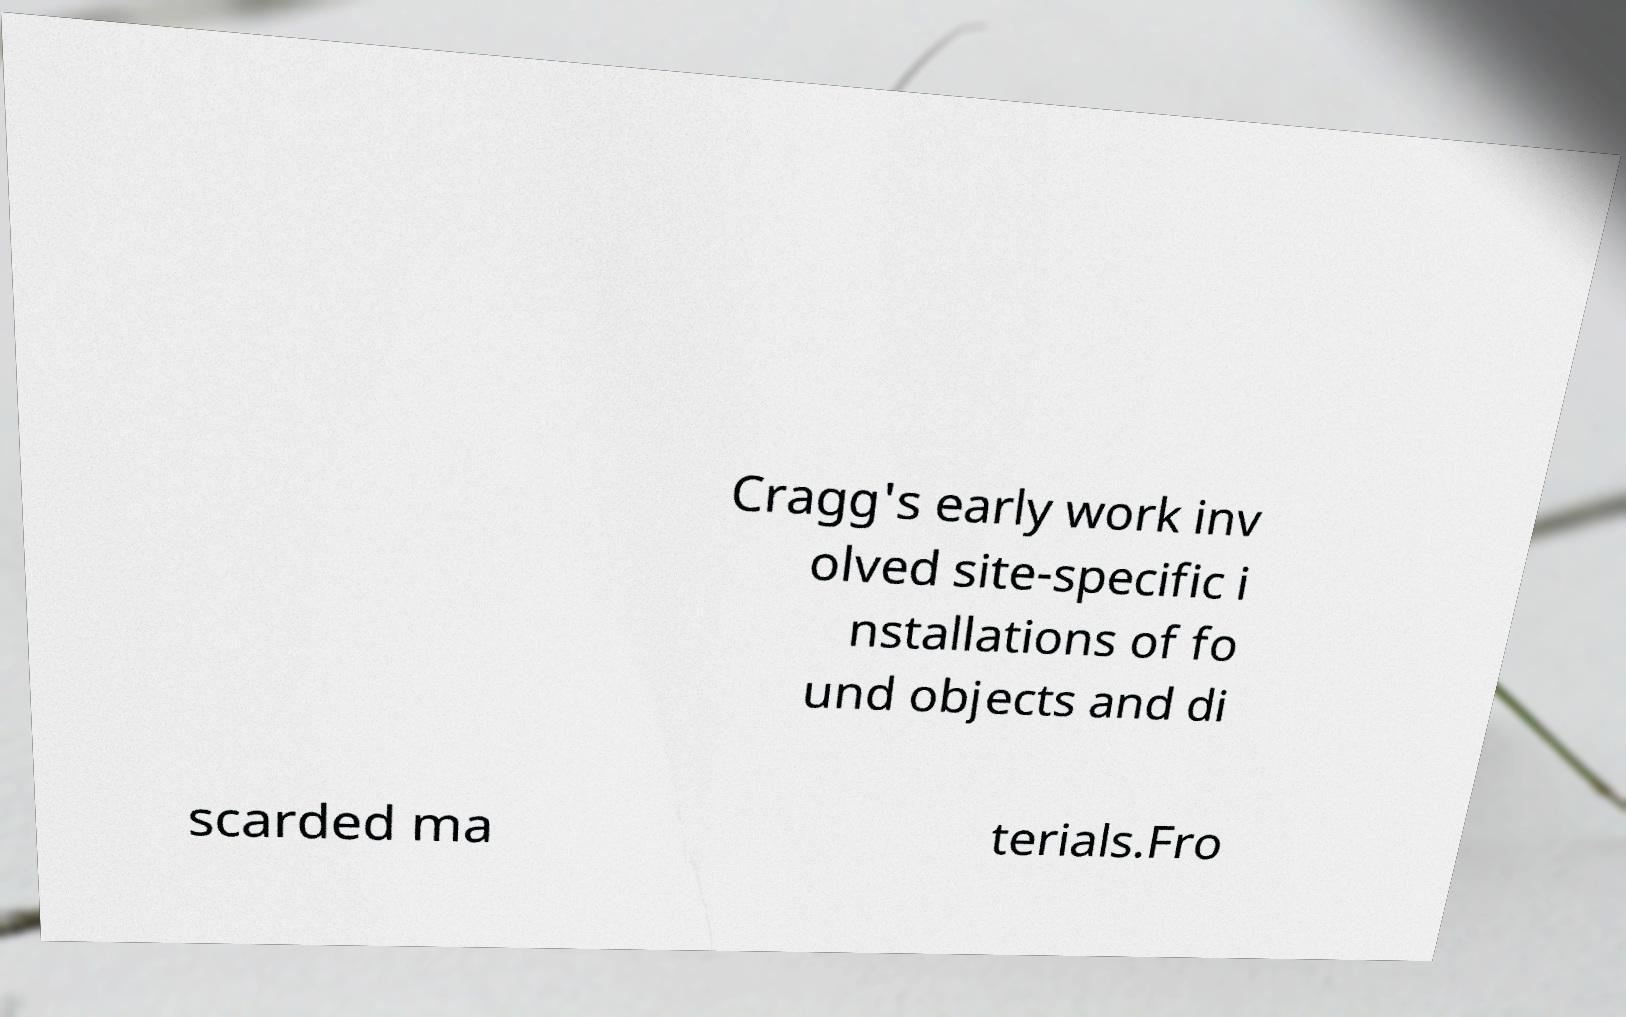Could you assist in decoding the text presented in this image and type it out clearly? Cragg's early work inv olved site-specific i nstallations of fo und objects and di scarded ma terials.Fro 